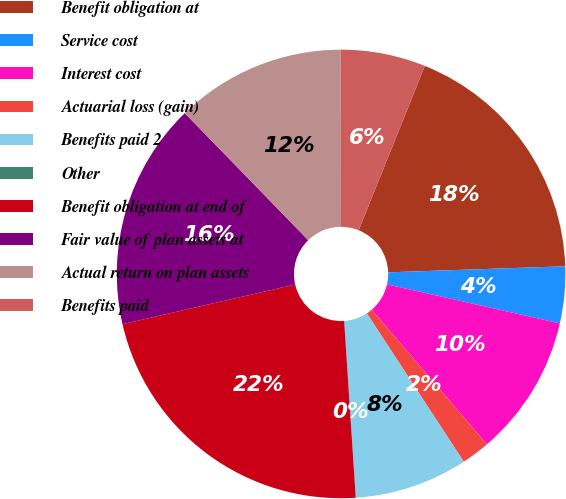<chart> <loc_0><loc_0><loc_500><loc_500><pie_chart><fcel>Benefit obligation at<fcel>Service cost<fcel>Interest cost<fcel>Actuarial loss (gain)<fcel>Benefits paid 2<fcel>Other<fcel>Benefit obligation at end of<fcel>Fair value of plan assets at<fcel>Actual return on plan assets<fcel>Benefits paid<nl><fcel>18.36%<fcel>4.08%<fcel>10.2%<fcel>2.05%<fcel>8.16%<fcel>0.01%<fcel>22.44%<fcel>16.32%<fcel>12.24%<fcel>6.12%<nl></chart> 